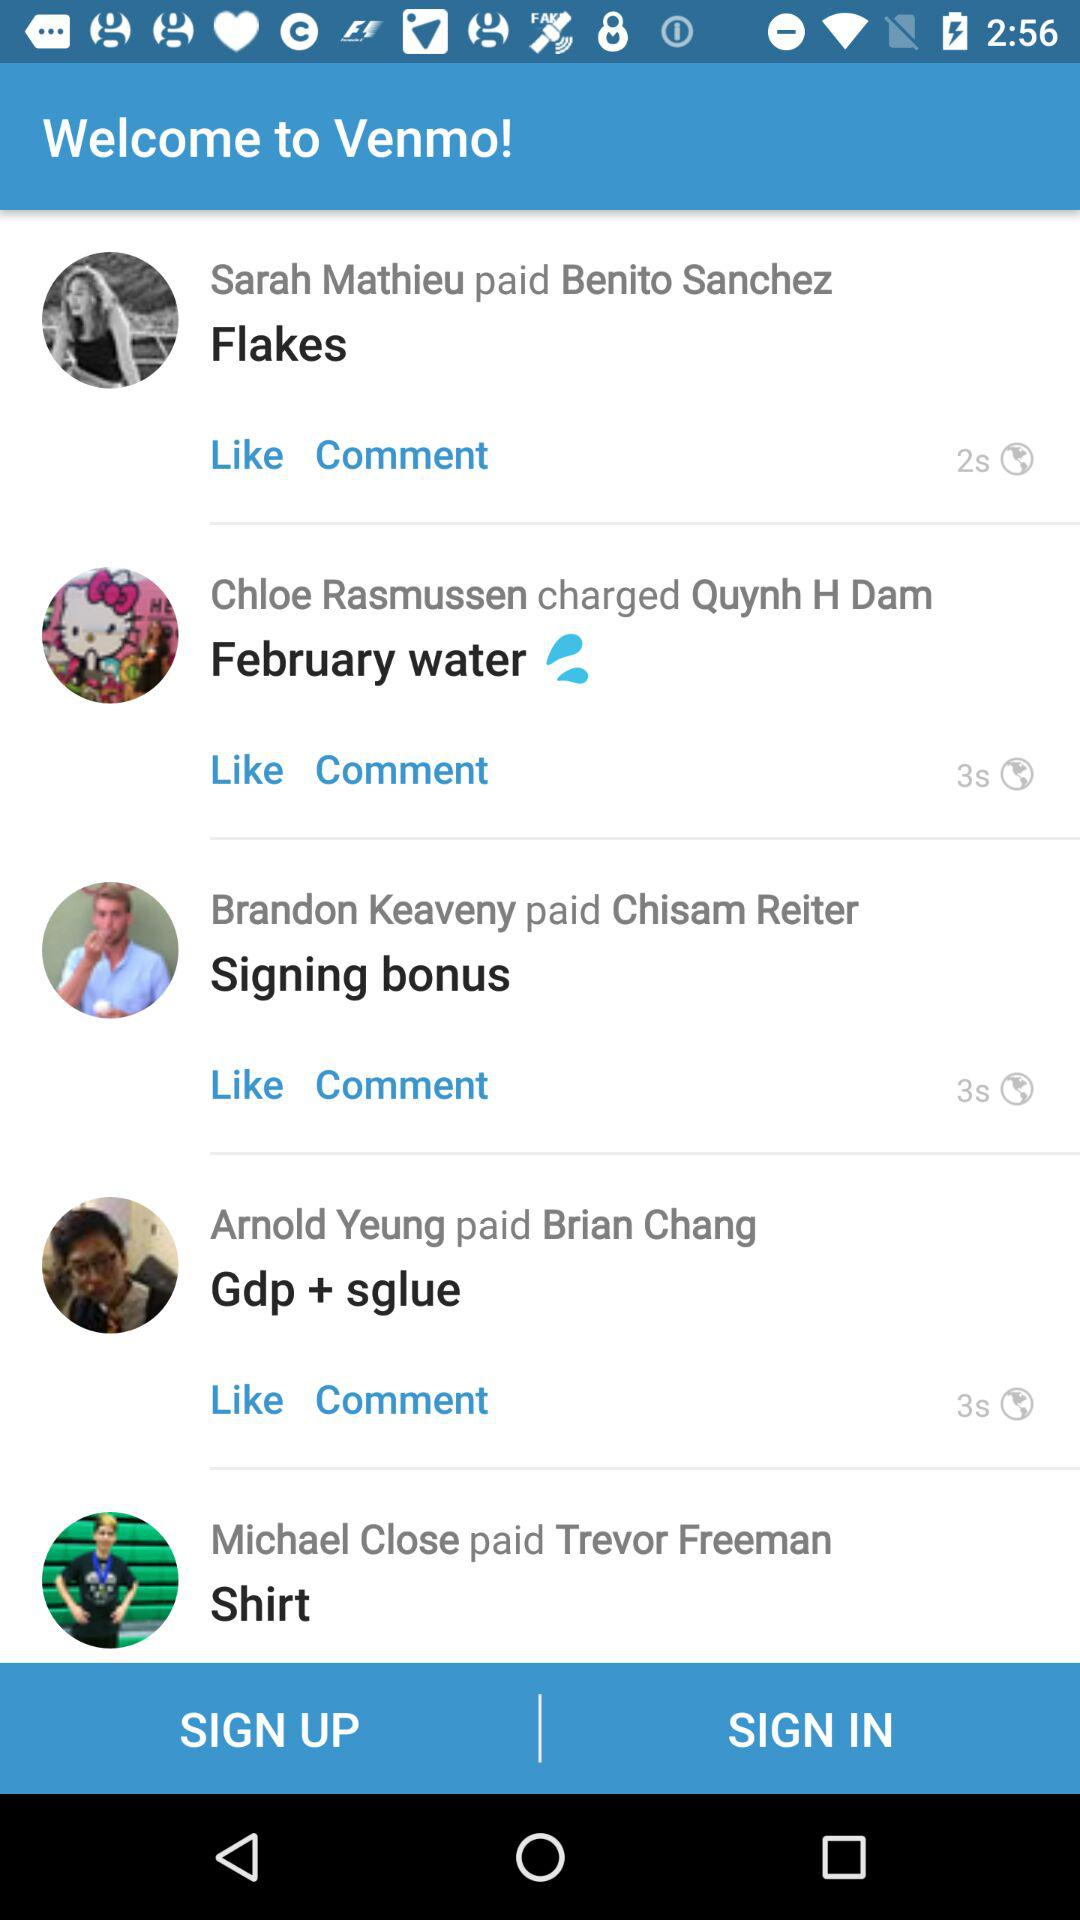How many transactions are there in total?
Answer the question using a single word or phrase. 4 